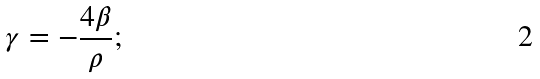<formula> <loc_0><loc_0><loc_500><loc_500>\gamma = - \frac { 4 \beta } { \rho } ;</formula> 